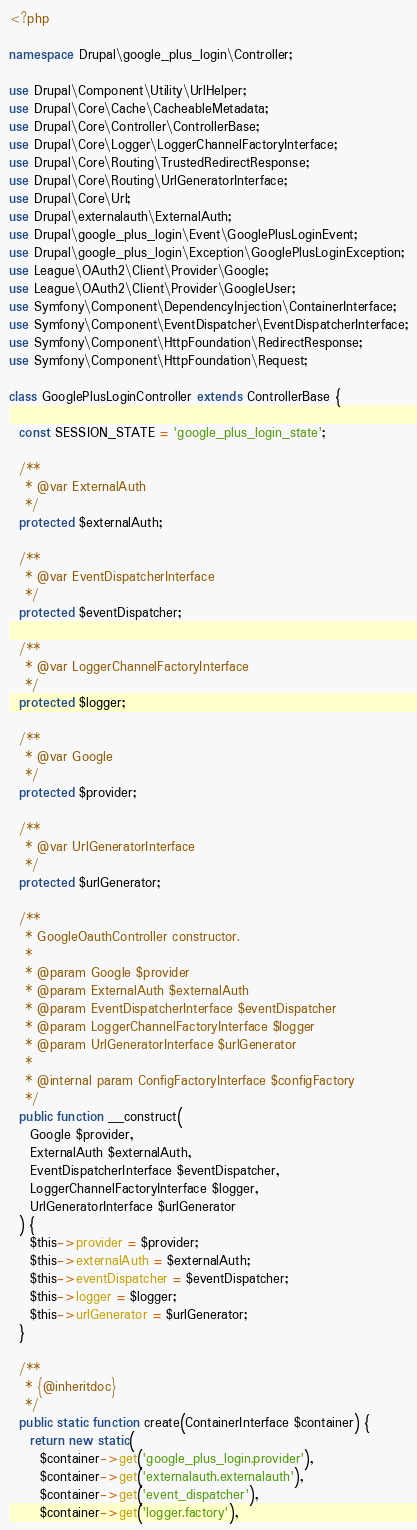Convert code to text. <code><loc_0><loc_0><loc_500><loc_500><_PHP_><?php

namespace Drupal\google_plus_login\Controller;

use Drupal\Component\Utility\UrlHelper;
use Drupal\Core\Cache\CacheableMetadata;
use Drupal\Core\Controller\ControllerBase;
use Drupal\Core\Logger\LoggerChannelFactoryInterface;
use Drupal\Core\Routing\TrustedRedirectResponse;
use Drupal\Core\Routing\UrlGeneratorInterface;
use Drupal\Core\Url;
use Drupal\externalauth\ExternalAuth;
use Drupal\google_plus_login\Event\GooglePlusLoginEvent;
use Drupal\google_plus_login\Exception\GooglePlusLoginException;
use League\OAuth2\Client\Provider\Google;
use League\OAuth2\Client\Provider\GoogleUser;
use Symfony\Component\DependencyInjection\ContainerInterface;
use Symfony\Component\EventDispatcher\EventDispatcherInterface;
use Symfony\Component\HttpFoundation\RedirectResponse;
use Symfony\Component\HttpFoundation\Request;

class GooglePlusLoginController extends ControllerBase {

  const SESSION_STATE = 'google_plus_login_state';

  /**
   * @var ExternalAuth
   */
  protected $externalAuth;

  /**
   * @var EventDispatcherInterface
   */
  protected $eventDispatcher;

  /**
   * @var LoggerChannelFactoryInterface
   */
  protected $logger;

  /**
   * @var Google
   */
  protected $provider;

  /**
   * @var UrlGeneratorInterface
   */
  protected $urlGenerator;

  /**
   * GoogleOauthController constructor.
   *
   * @param Google $provider
   * @param ExternalAuth $externalAuth
   * @param EventDispatcherInterface $eventDispatcher
   * @param LoggerChannelFactoryInterface $logger
   * @param UrlGeneratorInterface $urlGenerator
   *
   * @internal param ConfigFactoryInterface $configFactory
   */
  public function __construct(
    Google $provider,
    ExternalAuth $externalAuth,
    EventDispatcherInterface $eventDispatcher,
    LoggerChannelFactoryInterface $logger,
    UrlGeneratorInterface $urlGenerator
  ) {
    $this->provider = $provider;
    $this->externalAuth = $externalAuth;
    $this->eventDispatcher = $eventDispatcher;
    $this->logger = $logger;
    $this->urlGenerator = $urlGenerator;
  }

  /**
   * {@inheritdoc}
   */
  public static function create(ContainerInterface $container) {
    return new static(
      $container->get('google_plus_login.provider'),
      $container->get('externalauth.externalauth'),
      $container->get('event_dispatcher'),
      $container->get('logger.factory'),</code> 